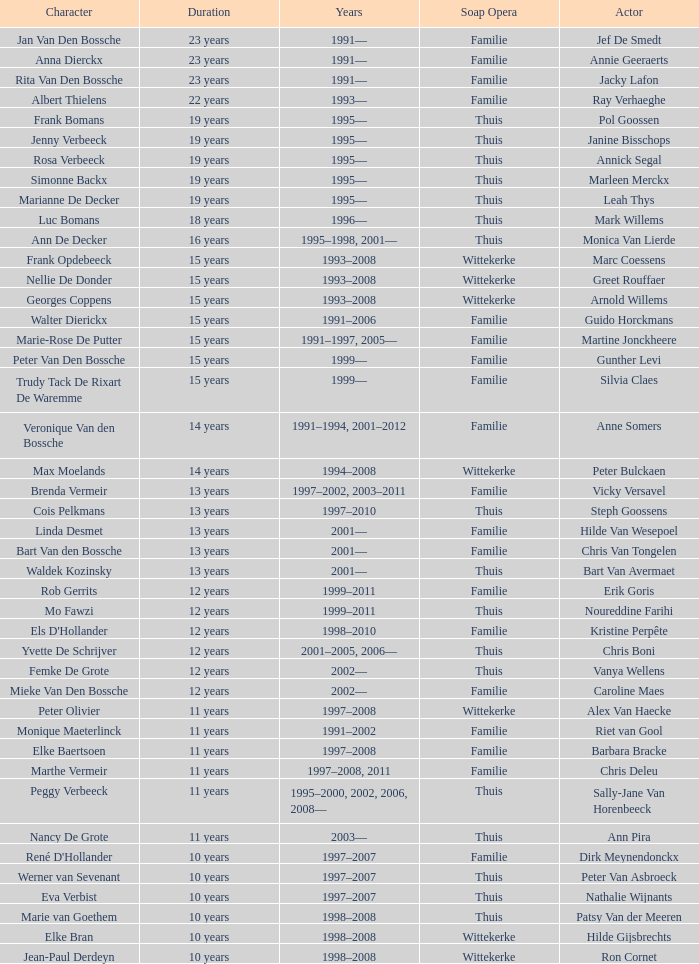What character did Vicky Versavel play for 13 years? Brenda Vermeir. 